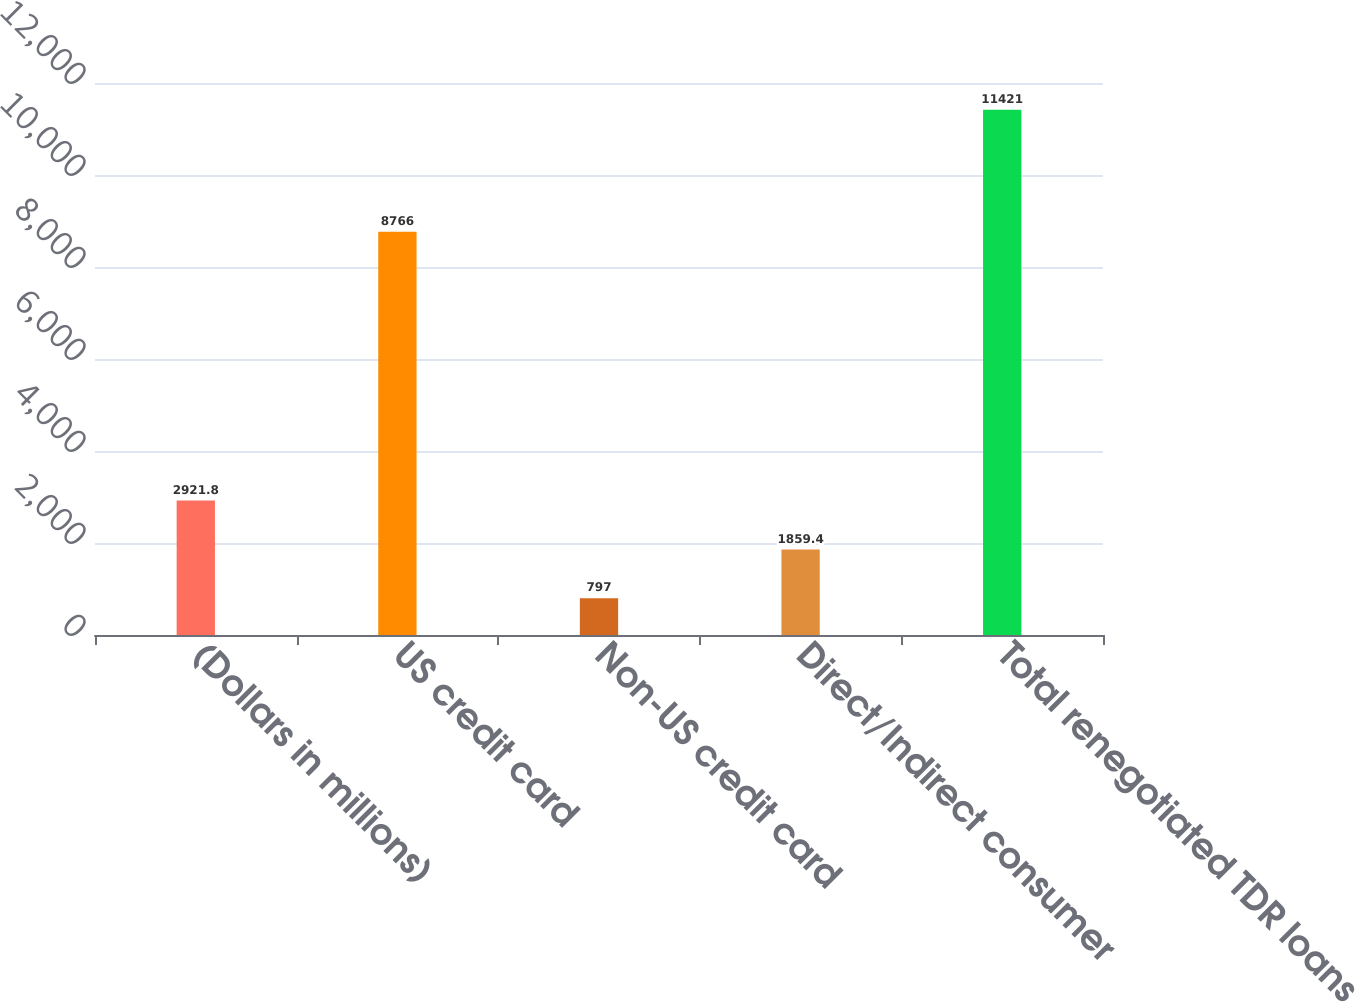Convert chart to OTSL. <chart><loc_0><loc_0><loc_500><loc_500><bar_chart><fcel>(Dollars in millions)<fcel>US credit card<fcel>Non-US credit card<fcel>Direct/Indirect consumer<fcel>Total renegotiated TDR loans<nl><fcel>2921.8<fcel>8766<fcel>797<fcel>1859.4<fcel>11421<nl></chart> 